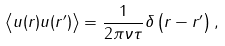Convert formula to latex. <formula><loc_0><loc_0><loc_500><loc_500>\left \langle u ( { r } ) u ( { r } ^ { \prime } ) \right \rangle = \frac { 1 } { 2 \pi \nu \tau } \delta \left ( { r } - { r } ^ { \prime } \right ) ,</formula> 